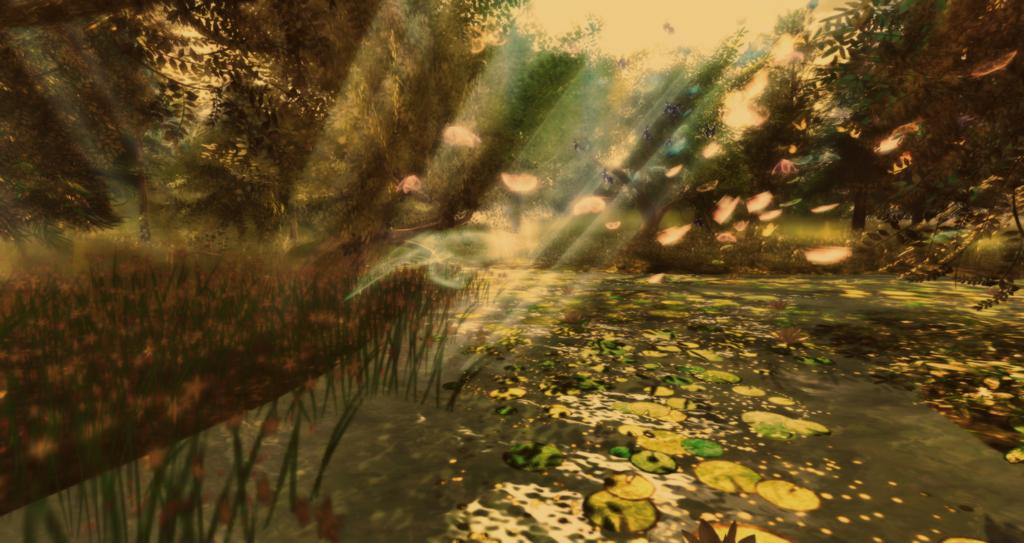What is the main subject of the image? The main subject of the image is an edited image of a pond. What can be seen in the background of the image? There are trees visible in the background of the image. What is the source of light in the image? Sun rays are present in the image. What type of industry can be seen in the image? There is no industry present in the image; it features an edited image of a pond with trees in the background and sun rays. Can you tell me how many beads are scattered around the pond in the image? There are no beads present in the image; it features an edited image of a pond with trees in the background and sun rays. 